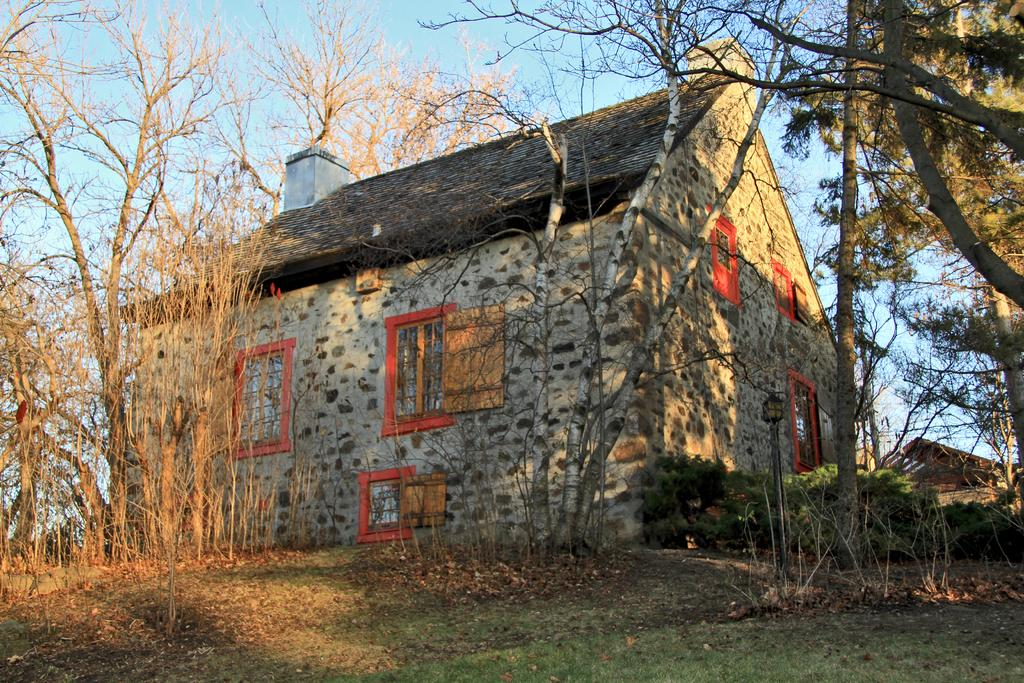What type of vegetation can be seen in the image? There is grass, plants, and trees in the image. What type of structure is present in the image? There is a house in the image. What feature of the house is visible in the image? There are windows in the image. What can be seen in the background of the image? The sky is visible in the background of the image. What type of flesh can be seen in the image? There is no flesh visible in the image; it primarily features vegetation and a house. What design elements can be seen on the trees in the image? The provided facts do not mention any specific design elements on the trees, so we cannot answer this question definitively. 